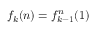Convert formula to latex. <formula><loc_0><loc_0><loc_500><loc_500>f _ { k } ( n ) = f _ { k - 1 } ^ { n } ( 1 )</formula> 